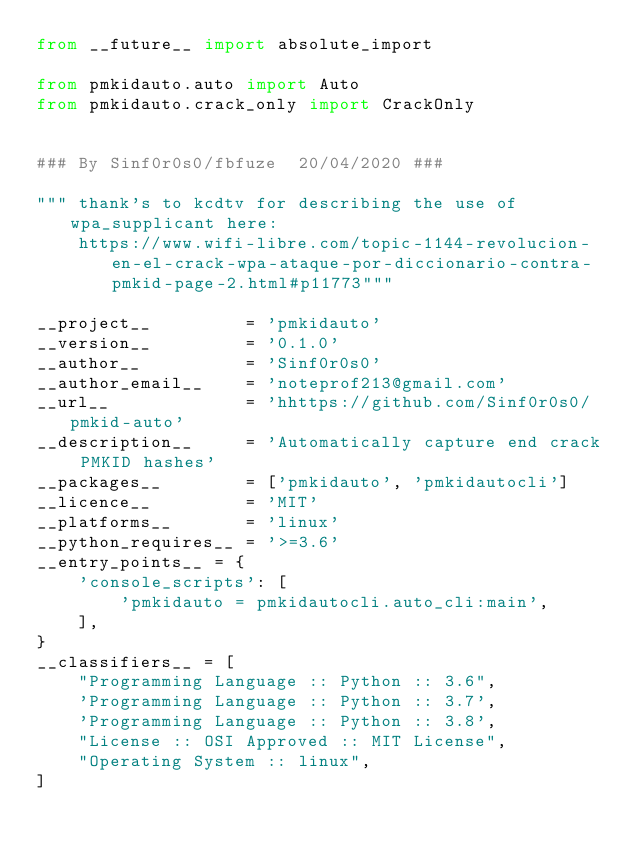<code> <loc_0><loc_0><loc_500><loc_500><_Python_>from __future__ import absolute_import

from pmkidauto.auto import Auto
from pmkidauto.crack_only import CrackOnly


### By Sinf0r0s0/fbfuze  20/04/2020 ###

""" thank's to kcdtv for describing the use of wpa_supplicant here: 
    https://www.wifi-libre.com/topic-1144-revolucion-en-el-crack-wpa-ataque-por-diccionario-contra-pmkid-page-2.html#p11773"""

__project__         = 'pmkidauto'
__version__         = '0.1.0'
__author__          = 'Sinf0r0s0'
__author_email__    = 'noteprof213@gmail.com'
__url__             = 'hhttps://github.com/Sinf0r0s0/pmkid-auto'
__description__     = 'Automatically capture end crack PMKID hashes'
__packages__        = ['pmkidauto', 'pmkidautocli']
__licence__         = 'MIT'
__platforms__       = 'linux'
__python_requires__ = '>=3.6'
__entry_points__ = {
    'console_scripts': [
        'pmkidauto = pmkidautocli.auto_cli:main',
    ],
}
__classifiers__ = [
    "Programming Language :: Python :: 3.6",
    'Programming Language :: Python :: 3.7',
    'Programming Language :: Python :: 3.8',
    "License :: OSI Approved :: MIT License",
    "Operating System :: linux",
]
</code> 